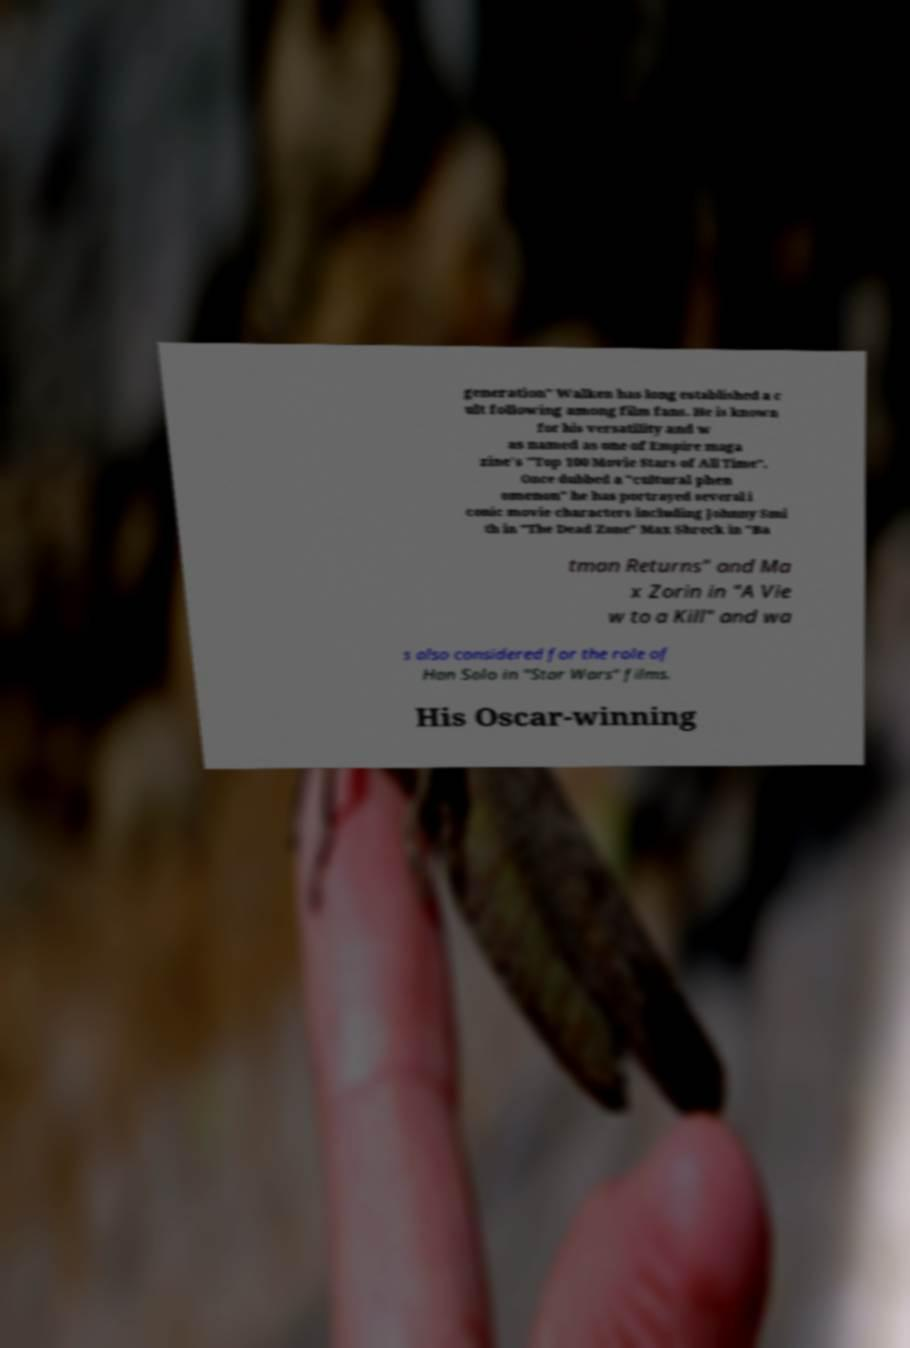Could you extract and type out the text from this image? generation" Walken has long established a c ult following among film fans. He is known for his versatility and w as named as one of Empire maga zine's "Top 100 Movie Stars of All Time". Once dubbed a "cultural phen omenon" he has portrayed several i conic movie characters including Johnny Smi th in "The Dead Zone" Max Shreck in "Ba tman Returns" and Ma x Zorin in "A Vie w to a Kill" and wa s also considered for the role of Han Solo in "Star Wars" films. His Oscar-winning 